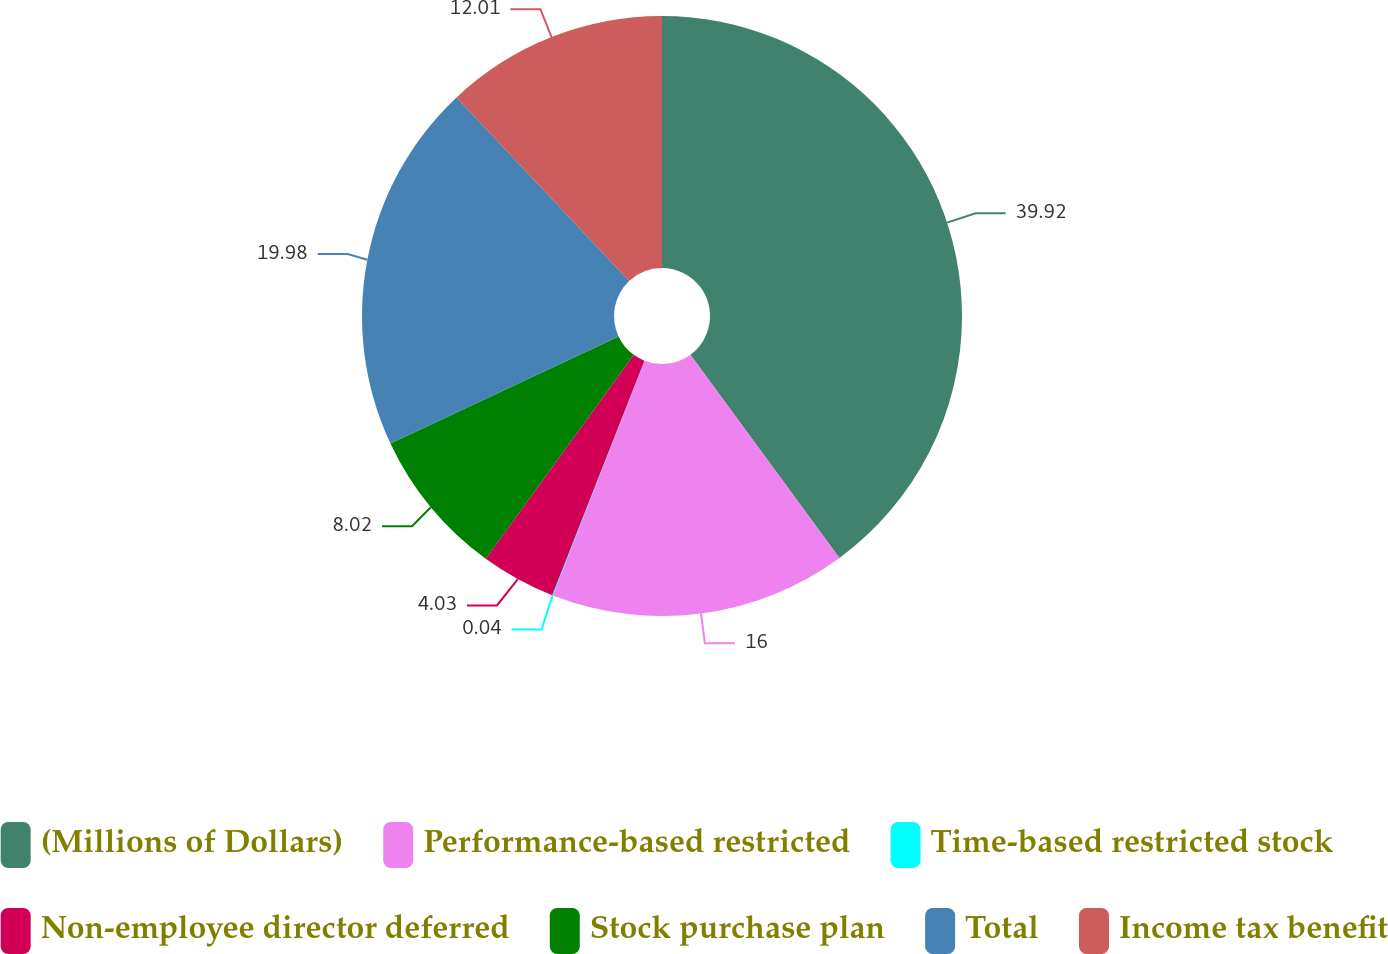Convert chart. <chart><loc_0><loc_0><loc_500><loc_500><pie_chart><fcel>(Millions of Dollars)<fcel>Performance-based restricted<fcel>Time-based restricted stock<fcel>Non-employee director deferred<fcel>Stock purchase plan<fcel>Total<fcel>Income tax benefit<nl><fcel>39.93%<fcel>16.0%<fcel>0.04%<fcel>4.03%<fcel>8.02%<fcel>19.98%<fcel>12.01%<nl></chart> 